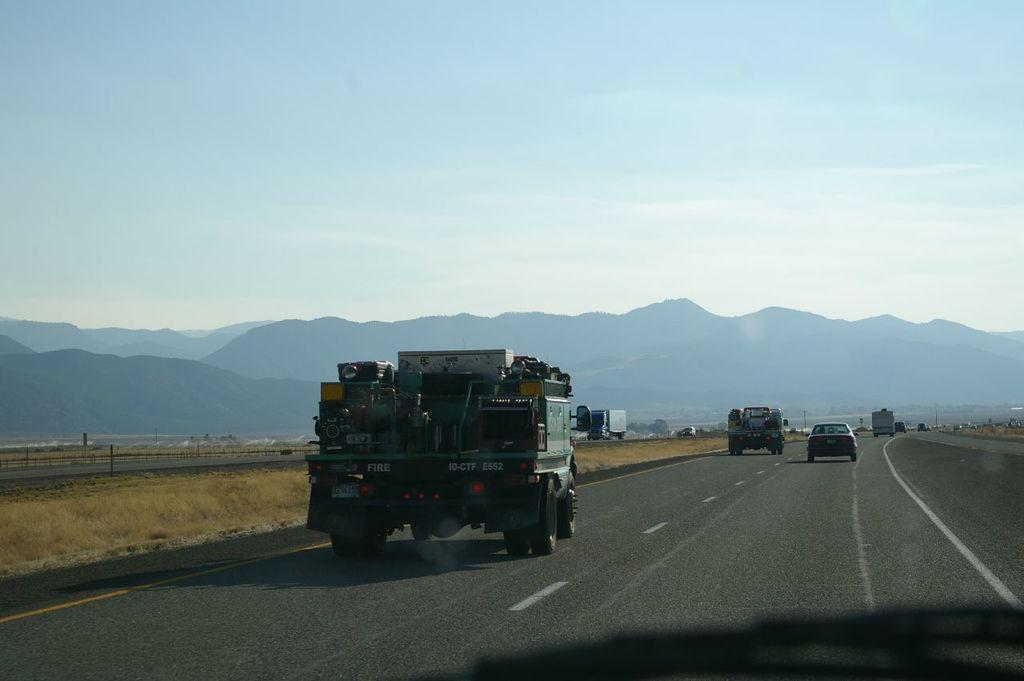What is the main subject of the image? The main subject of the image is a group of vehicles. Where are the vehicles located in the image? The vehicles are parked on the road in the image. What can be seen in the background of the image? Mountains and the sky are visible in the background of the image. What type of head can be seen on the vehicles in the image? There are no heads visible on the vehicles in the image; they are inanimate objects. 